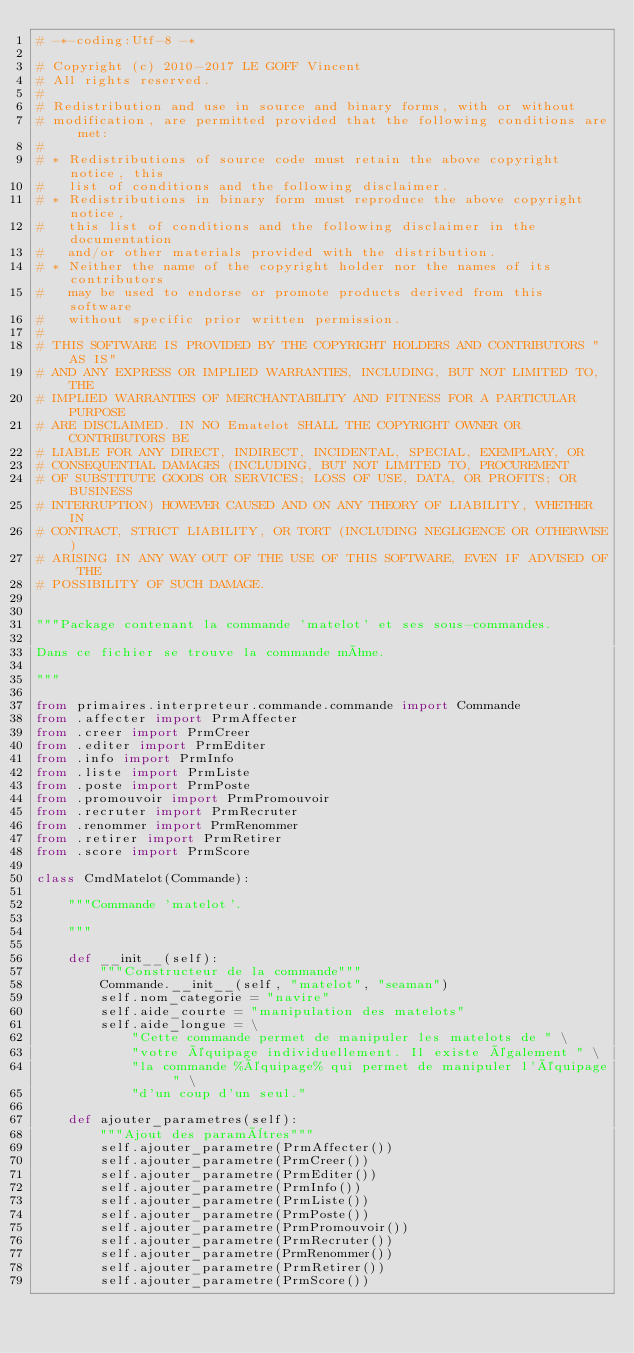Convert code to text. <code><loc_0><loc_0><loc_500><loc_500><_Python_># -*-coding:Utf-8 -*

# Copyright (c) 2010-2017 LE GOFF Vincent
# All rights reserved.
#
# Redistribution and use in source and binary forms, with or without
# modification, are permitted provided that the following conditions are met:
#
# * Redistributions of source code must retain the above copyright notice, this
#   list of conditions and the following disclaimer.
# * Redistributions in binary form must reproduce the above copyright notice,
#   this list of conditions and the following disclaimer in the documentation
#   and/or other materials provided with the distribution.
# * Neither the name of the copyright holder nor the names of its contributors
#   may be used to endorse or promote products derived from this software
#   without specific prior written permission.
#
# THIS SOFTWARE IS PROVIDED BY THE COPYRIGHT HOLDERS AND CONTRIBUTORS "AS IS"
# AND ANY EXPRESS OR IMPLIED WARRANTIES, INCLUDING, BUT NOT LIMITED TO, THE
# IMPLIED WARRANTIES OF MERCHANTABILITY AND FITNESS FOR A PARTICULAR PURPOSE
# ARE DISCLAIMED. IN NO Ematelot SHALL THE COPYRIGHT OWNER OR CONTRIBUTORS BE
# LIABLE FOR ANY DIRECT, INDIRECT, INCIDENTAL, SPECIAL, EXEMPLARY, OR
# CONSEQUENTIAL DAMAGES (INCLUDING, BUT NOT LIMITED TO, PROCUREMENT
# OF SUBSTITUTE GOODS OR SERVICES; LOSS OF USE, DATA, OR PROFITS; OR BUSINESS
# INTERRUPTION) HOWEVER CAUSED AND ON ANY THEORY OF LIABILITY, WHETHER IN
# CONTRACT, STRICT LIABILITY, OR TORT (INCLUDING NEGLIGENCE OR OTHERWISE)
# ARISING IN ANY WAY OUT OF THE USE OF THIS SOFTWARE, EVEN IF ADVISED OF THE
# POSSIBILITY OF SUCH DAMAGE.


"""Package contenant la commande 'matelot' et ses sous-commandes.

Dans ce fichier se trouve la commande même.

"""

from primaires.interpreteur.commande.commande import Commande
from .affecter import PrmAffecter
from .creer import PrmCreer
from .editer import PrmEditer
from .info import PrmInfo
from .liste import PrmListe
from .poste import PrmPoste
from .promouvoir import PrmPromouvoir
from .recruter import PrmRecruter
from .renommer import PrmRenommer
from .retirer import PrmRetirer
from .score import PrmScore

class CmdMatelot(Commande):

    """Commande 'matelot'.

    """

    def __init__(self):
        """Constructeur de la commande"""
        Commande.__init__(self, "matelot", "seaman")
        self.nom_categorie = "navire"
        self.aide_courte = "manipulation des matelots"
        self.aide_longue = \
            "Cette commande permet de manipuler les matelots de " \
            "votre équipage individuellement. Il existe également " \
            "la commande %équipage% qui permet de manipuler l'équipage " \
            "d'un coup d'un seul."

    def ajouter_parametres(self):
        """Ajout des paramètres"""
        self.ajouter_parametre(PrmAffecter())
        self.ajouter_parametre(PrmCreer())
        self.ajouter_parametre(PrmEditer())
        self.ajouter_parametre(PrmInfo())
        self.ajouter_parametre(PrmListe())
        self.ajouter_parametre(PrmPoste())
        self.ajouter_parametre(PrmPromouvoir())
        self.ajouter_parametre(PrmRecruter())
        self.ajouter_parametre(PrmRenommer())
        self.ajouter_parametre(PrmRetirer())
        self.ajouter_parametre(PrmScore())
</code> 